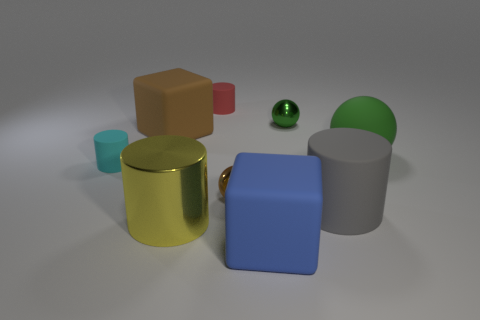Subtract all matte spheres. How many spheres are left? 2 Add 1 large gray cubes. How many objects exist? 10 Subtract all blocks. How many objects are left? 7 Subtract all red cylinders. How many green balls are left? 2 Subtract all blue cubes. How many cubes are left? 1 Add 4 cyan objects. How many cyan objects exist? 5 Subtract 0 purple blocks. How many objects are left? 9 Subtract 3 cylinders. How many cylinders are left? 1 Subtract all blue cubes. Subtract all purple spheres. How many cubes are left? 1 Subtract all brown shiny cubes. Subtract all small metallic objects. How many objects are left? 7 